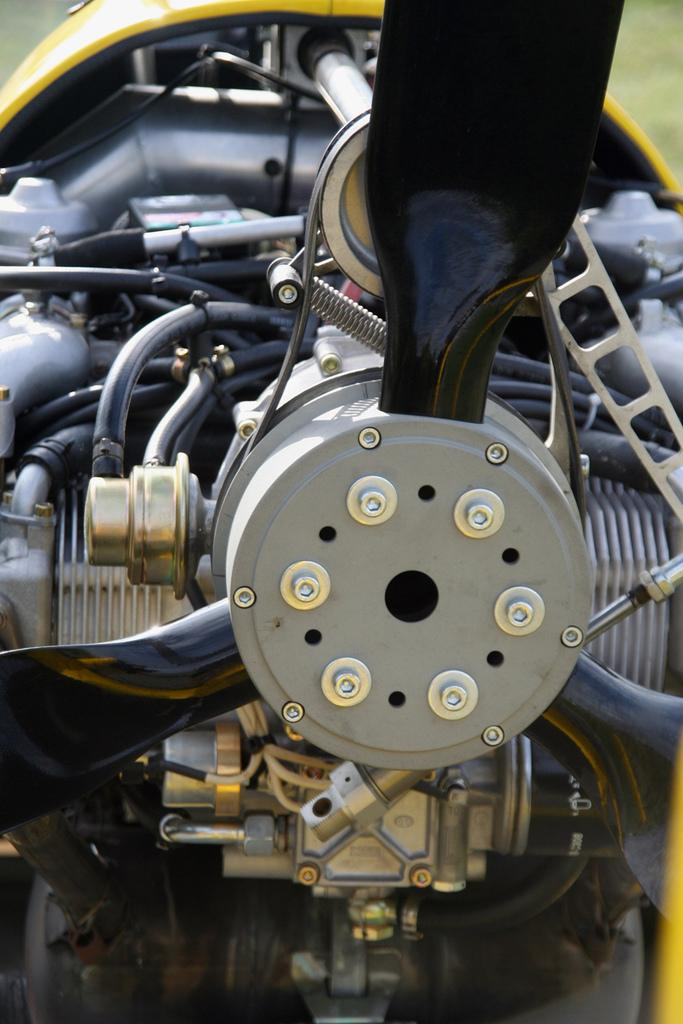What type of objects are present in the image? The image contains engine parts of a vehicle. Can you describe the engine parts in more detail? Unfortunately, the facts provided do not give specific details about the engine parts. Are there any other objects or elements visible in the image besides the engine parts? No additional information is given about other objects or elements in the image. What type of bean is being used to hold the brick in the image? There is no bean or brick present in the image; it contains engine parts of a vehicle. 